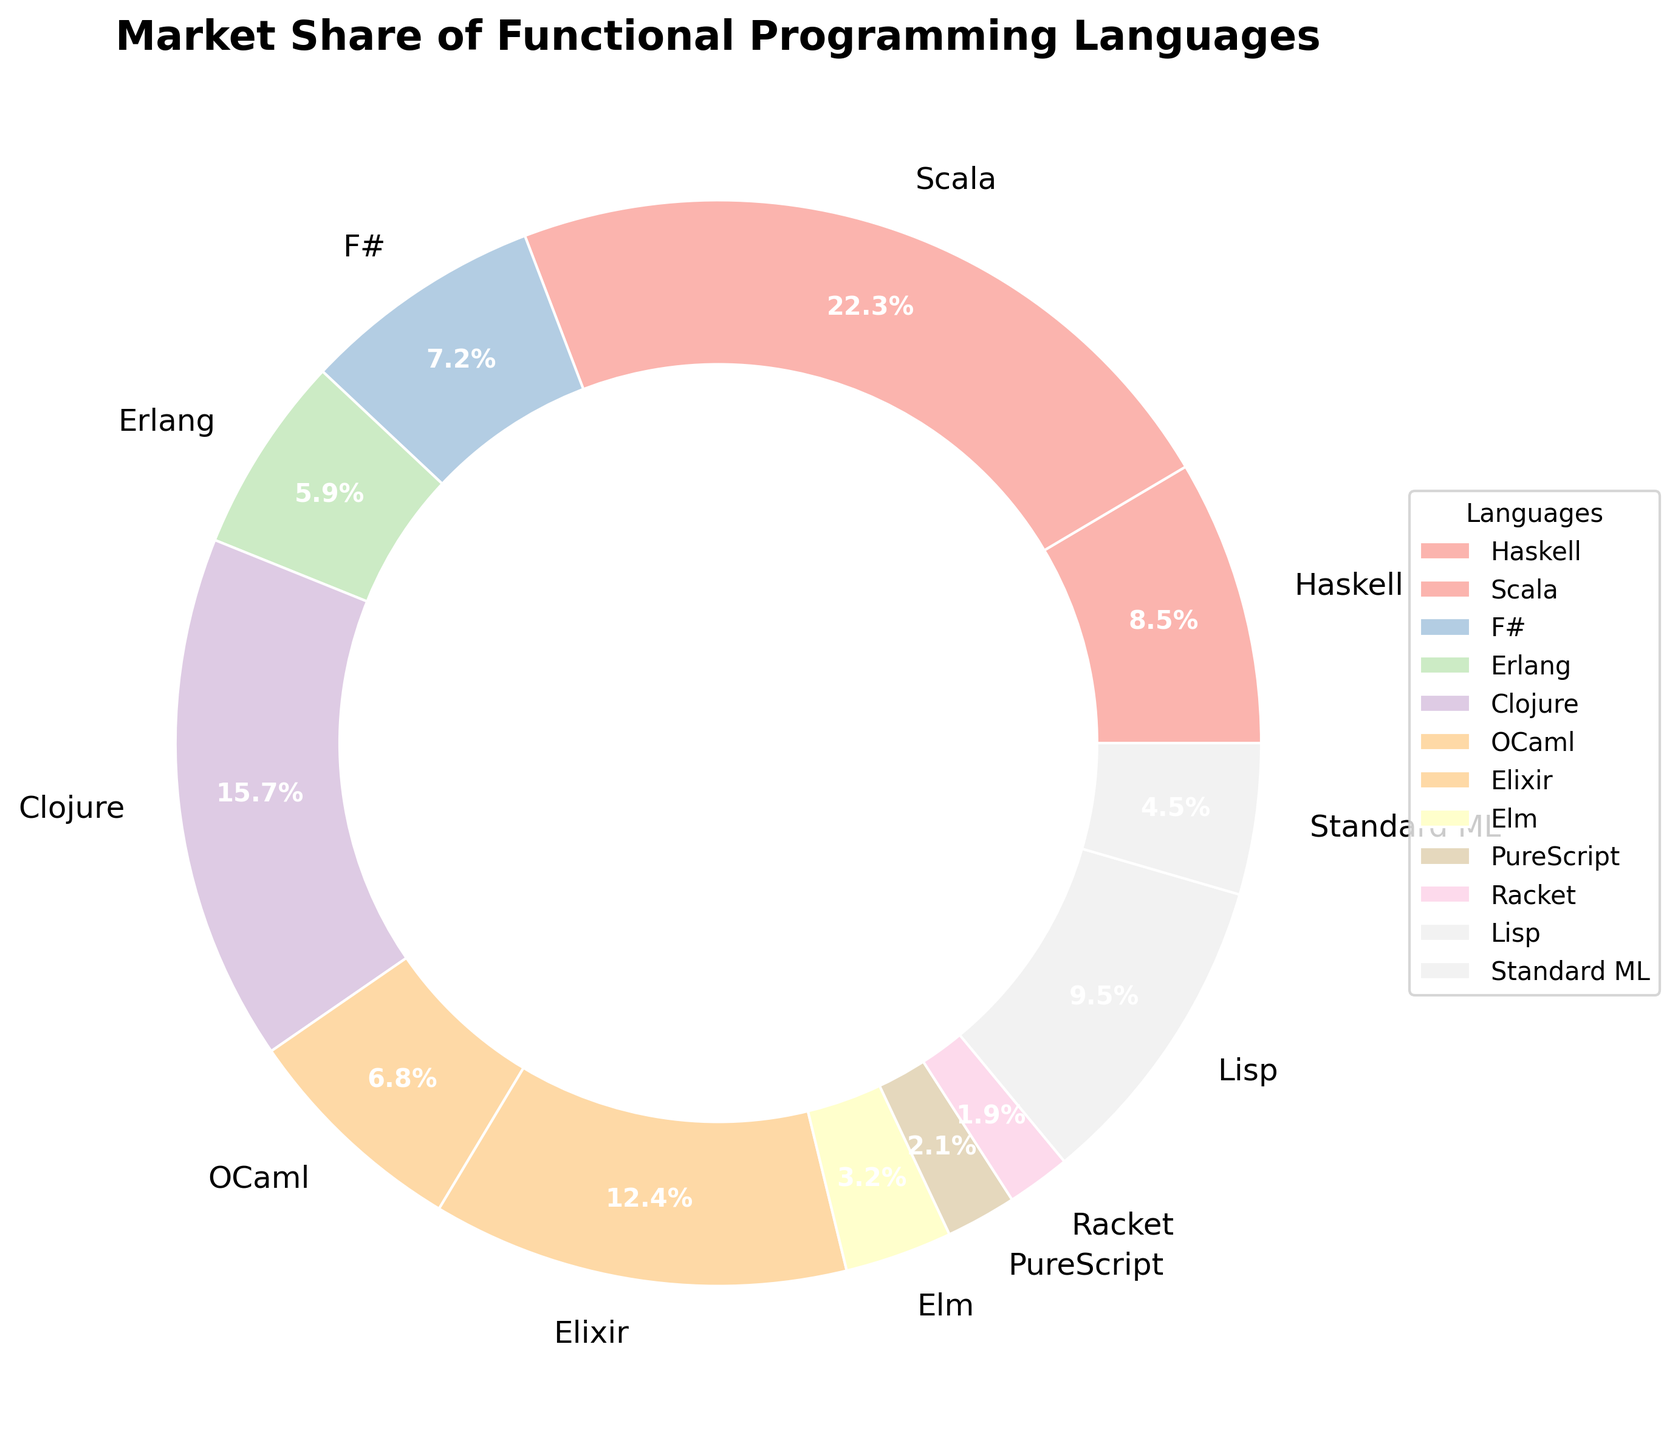What's the market share of Haskell? The pie chart shows the market share of Haskell as one of the segments. By looking at the label on Haskell's segment, we see that it is 8.5%.
Answer: 8.5% Which language has the highest market share? By inspecting the chart, we can see that the segment for Scala is the largest. The label on Scala's segment indicates a market share of 22.3%, which is the highest among the given languages.
Answer: Scala What is the sum of the market shares of F#, Erlang, and Standard ML? To find the sum, we identify the market shares of F# (7.2%), Erlang (5.9%), and Standard ML (4.5%) from the pie chart. Adding them together: 7.2 + 5.9 + 4.5 = 17.6%.
Answer: 17.6% Which language has a market share greater than but closest to Haskell? First, find Haskell's market share, which is 8.5%. Then look at the segments with a market share greater than 8.5%. The closest one to Haskell is Lisp with 9.5%.
Answer: Lisp How does the market share of Lisp compare to that of Elixir? The pie chart shows that Lisp has a market share of 9.5% whereas Elixir has a market share of 12.4%. Comparing these, Elixir's market share is higher than that of Lisp.
Answer: Elixir > Lisp Which three languages have the lowest market shares and what are they combined? Identifying from the pie chart, the three languages with the lowest market shares are Racket (1.9%), PureScript (2.1%), and Elm (3.2%). Summing these values: 1.9 + 2.1 + 3.2 = 7.2%.
Answer: 7.2% What's the difference in market share between Clojure and OCaml? By looking at the pie chart, Clojure's market share is 15.7% and OCaml's is 6.8%. The difference is calculated as 15.7 - 6.8 = 8.9%.
Answer: 8.9% What fraction of the total market is represented by Scala and Clojure combined? Scala has a market share of 22.3% and Clojure has 15.7%. Adding these gives 22.3 + 15.7 = 38%. Since the total market is represented by 100%, the fraction is 38/100 or 0.38.
Answer: 0.38 What language has a segment with a pastel green color? Each segment of the pie chart is colored with a different pastel color. By looking at the chart, we identify that Haskell's segment is in pastel green.
Answer: Haskell 